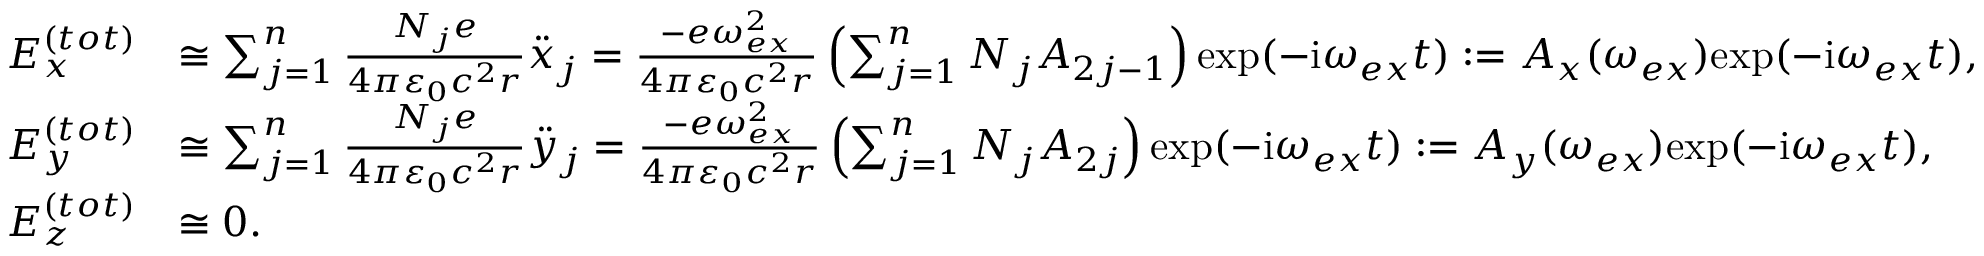Convert formula to latex. <formula><loc_0><loc_0><loc_500><loc_500>\begin{array} { r l } { E _ { x } ^ { ( t o t ) } } & { \cong \sum _ { j = 1 } ^ { n } \frac { N _ { j } e } { 4 \pi \varepsilon _ { 0 } c ^ { 2 } r } \ddot { x } _ { j } = \frac { - e \omega _ { e x } ^ { 2 } } { 4 \pi \varepsilon _ { 0 } c ^ { 2 } r } \left ( \sum _ { j = 1 } ^ { n } N _ { j } A _ { 2 j - 1 } \right ) e x p ( - i \omega _ { e x } t ) \colon = A _ { x } ( \omega _ { e x } ) e x p ( - i \omega _ { e x } t ) , } \\ { E _ { y } ^ { ( t o t ) } } & { \cong \sum _ { j = 1 } ^ { n } \frac { N _ { j } e } { 4 \pi \varepsilon _ { 0 } c ^ { 2 } r } \ddot { y } _ { j } = \frac { - e \omega _ { e x } ^ { 2 } } { 4 \pi \varepsilon _ { 0 } c ^ { 2 } r } \left ( \sum _ { j = 1 } ^ { n } N _ { j } A _ { 2 j } \right ) e x p ( - i \omega _ { e x } t ) \colon = A _ { y } ( \omega _ { e x } ) e x p ( - i \omega _ { e x } t ) , } \\ { E _ { z } ^ { ( t o t ) } } & { \cong 0 . } \end{array}</formula> 